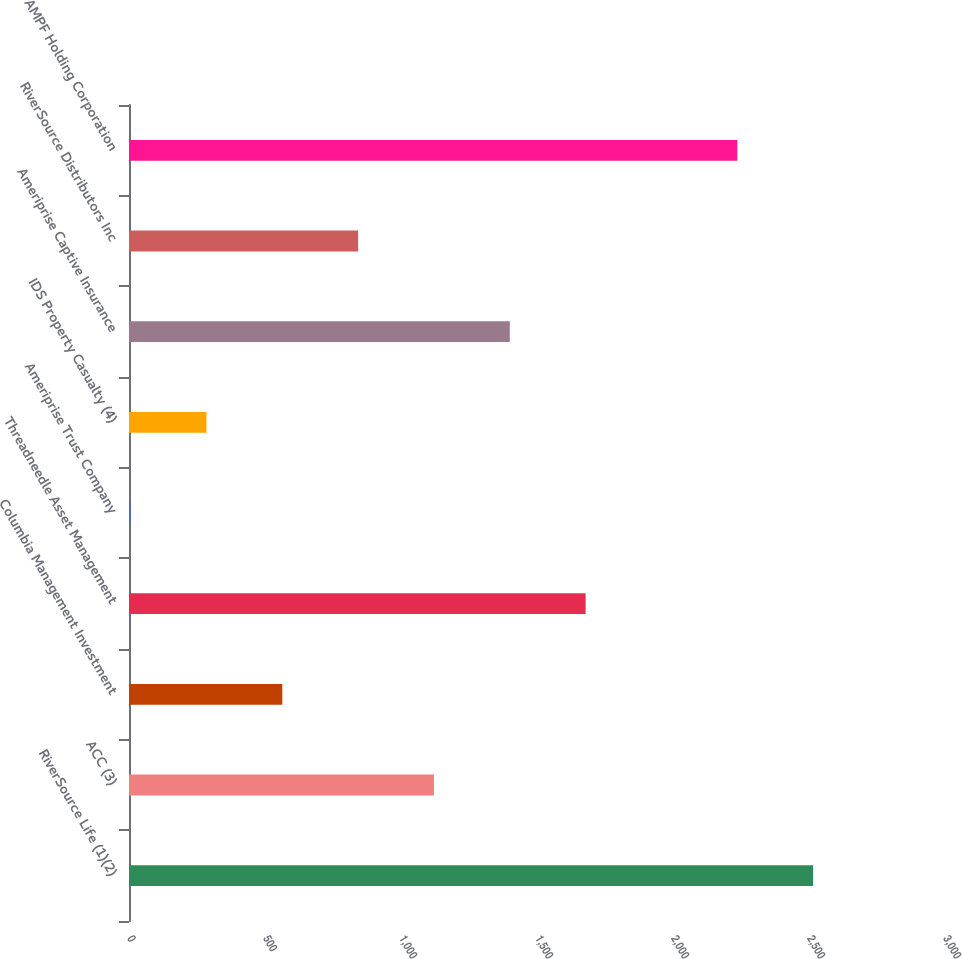Convert chart. <chart><loc_0><loc_0><loc_500><loc_500><bar_chart><fcel>RiverSource Life (1)(2)<fcel>ACC (3)<fcel>Columbia Management Investment<fcel>Threadneedle Asset Management<fcel>Ameriprise Trust Company<fcel>IDS Property Casualty (4)<fcel>Ameriprise Captive Insurance<fcel>RiverSource Distributors Inc<fcel>AMPF Holding Corporation<nl><fcel>2515.2<fcel>1121.2<fcel>563.6<fcel>1678.8<fcel>6<fcel>284.8<fcel>1400<fcel>842.4<fcel>2236.4<nl></chart> 